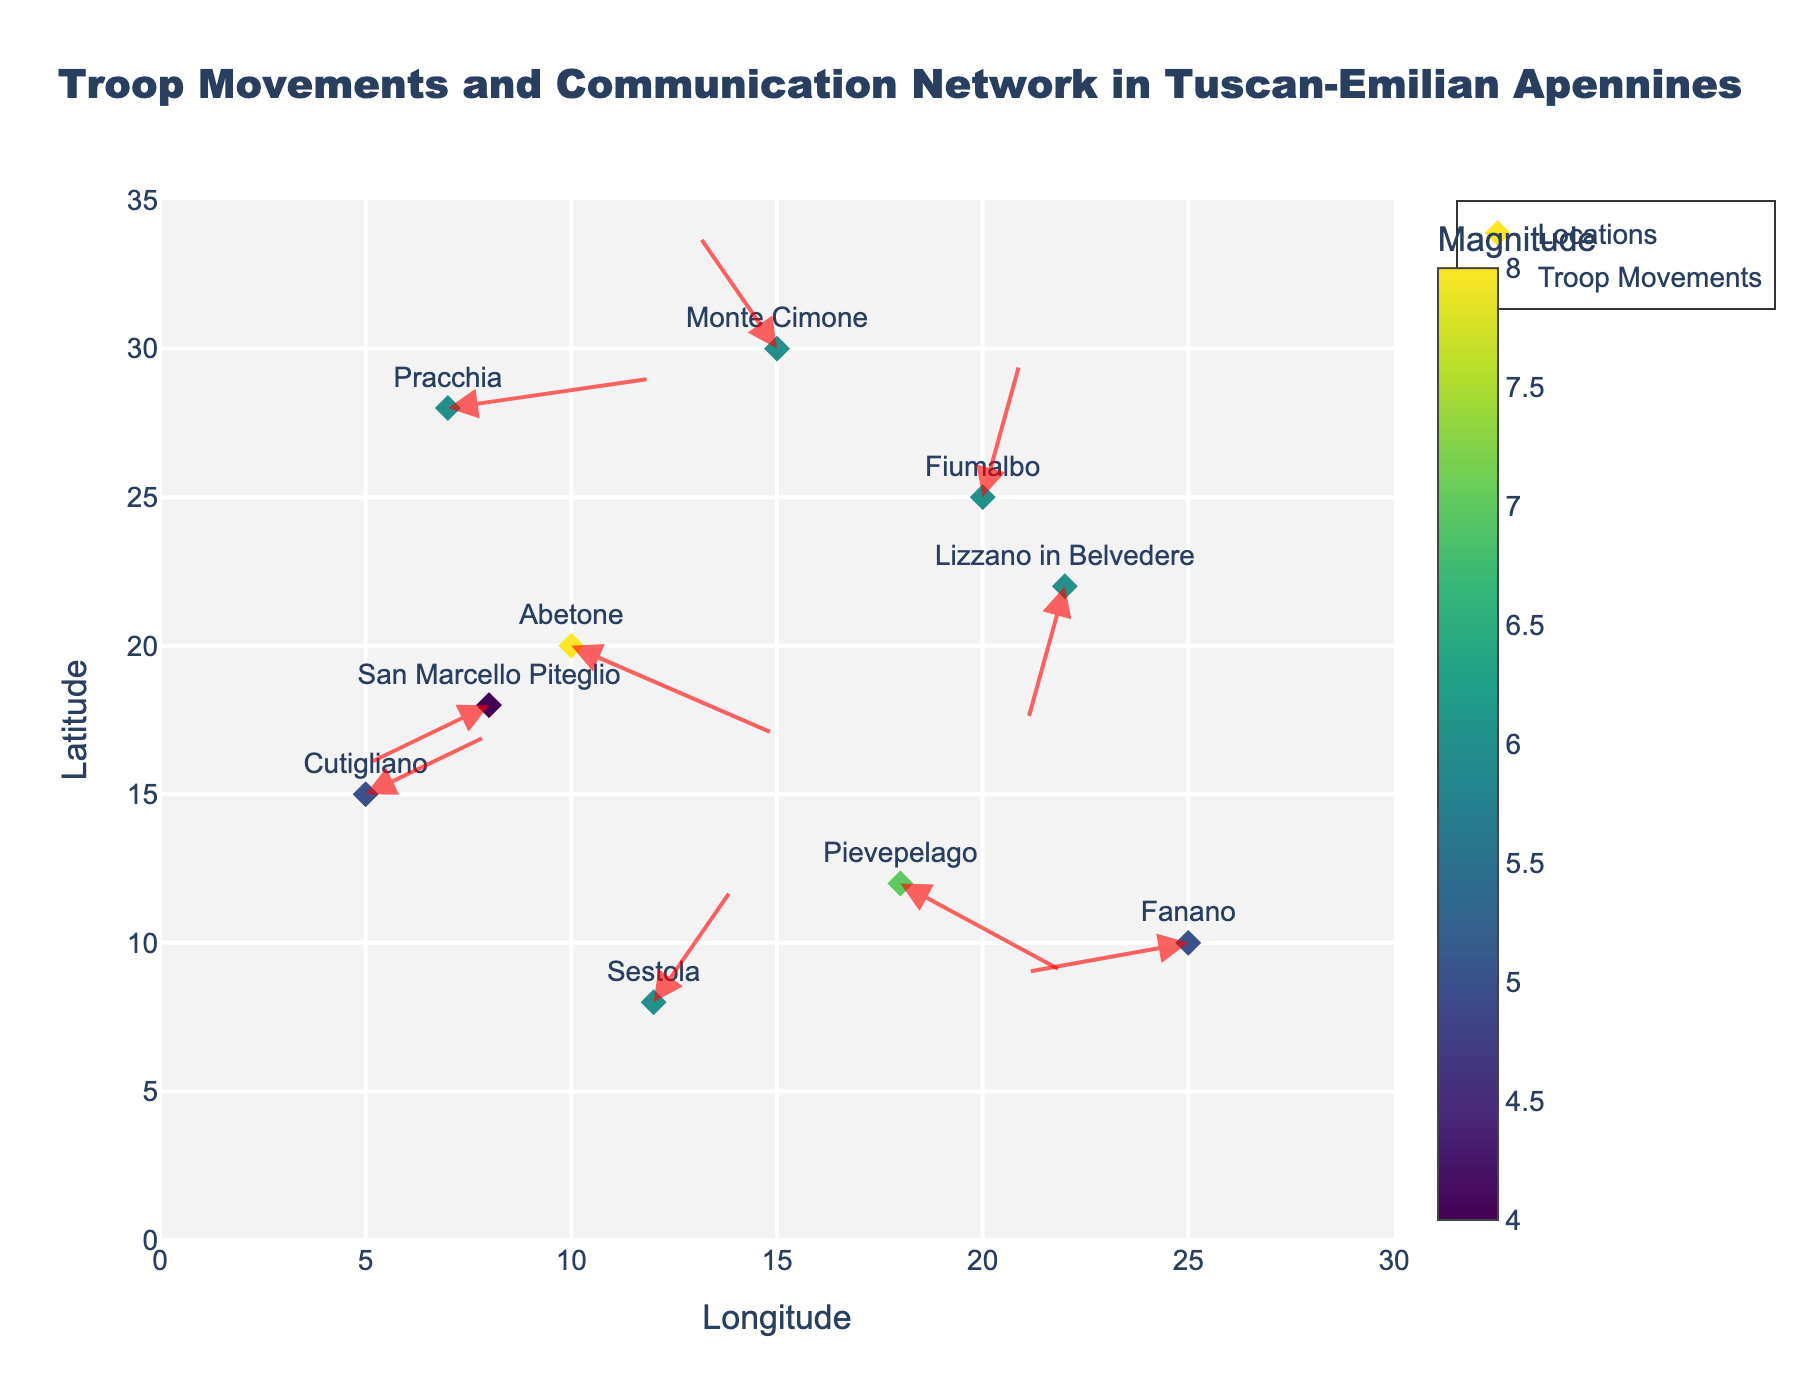What is the title of the plot? The title is mentioned at the top center of the plot and reads "Troop Movements and Communication Network in Tuscan-Emilian Apennines"
Answer: Troop Movements and Communication Network in Tuscan-Emilian Apennines Which location has the largest marker size? Marker sizes correspond to the 'magnitude' column in the data. By checking all magnitudes, Abetone has the largest with a magnitude of 8.
Answer: Abetone What colors are used to represent the magnitude of troop movements? The colors are based on the 'Viridis' colorscale and range from green to yellow, with a colorbar indicating this.
Answer: Green to Yellow How many locations are represented in the plot? To find the number of locations, count the number of unique entries in the 'location' column. Here, there are 10 unique locations shown in the plot.
Answer: 10 What is the x-coordinate and y-coordinate of the location with the arrow pointing straight up? The arrow representing this is at Fiumalbo with (1, 5) coordinates.
Answer: (20, 25) Compare the magnitudes of troop movements at Sestola and Lizzano in Belvedere. Which has a higher magnitude? Magnitudes for Sestola and Lizzano in Belvedere are both 6.
Answer: They are equal What is the average magnitude of troop movements in the displayed plot? To find this, sum the magnitudes and divide by the total number of locations: (8 + 6 + 5 + 5 + 6 + 4 + 7 + 6 + 6 + 6) / 10 = 5.9.
Answer: 5.9 Which location has the westernmost troop movement direction? Troop movements can be determined by the 'u' direction vector. The westernmost direction is given by the most negative 'u' value, which is for Fanano (-4).
Answer: Fanano Which location in the plot has a communication direction vector pointing south-west? A south-west pointing vector has negative u and v values. San Marcello Piteglio (-3, -2) corresponds to this description.
Answer: San Marcello Piteglio At which location does the arrow point in the north-east direction? An arrow pointing north-east has positive u and v values. The location that matches this is at Fiumalbo (1, 5).
Answer: Fiumalbo 